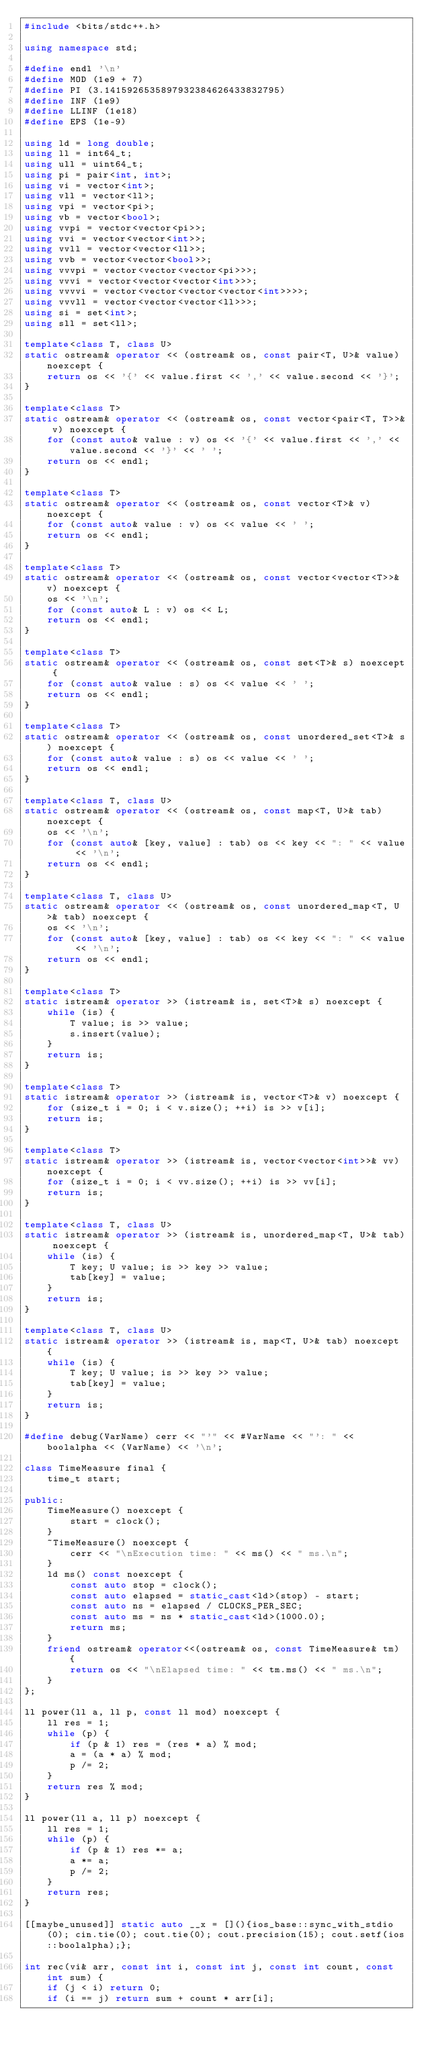Convert code to text. <code><loc_0><loc_0><loc_500><loc_500><_C++_>#include <bits/stdc++.h>

using namespace std;

#define endl '\n'
#define MOD (1e9 + 7)
#define PI (3.1415926535897932384626433832795)
#define INF (1e9)
#define LLINF (1e18)
#define EPS (1e-9)

using ld = long double;
using ll = int64_t;
using ull = uint64_t;
using pi = pair<int, int>;
using vi = vector<int>;
using vll = vector<ll>;
using vpi = vector<pi>;
using vb = vector<bool>;
using vvpi = vector<vector<pi>>;
using vvi = vector<vector<int>>;
using vvll = vector<vector<ll>>;
using vvb = vector<vector<bool>>;
using vvvpi = vector<vector<vector<pi>>>;
using vvvi = vector<vector<vector<int>>>;
using vvvvi = vector<vector<vector<vector<int>>>>;
using vvvll = vector<vector<vector<ll>>>;
using si = set<int>;
using sll = set<ll>;

template<class T, class U>
static ostream& operator << (ostream& os, const pair<T, U>& value) noexcept {
    return os << '{' << value.first << ',' << value.second << '}';
}

template<class T>
static ostream& operator << (ostream& os, const vector<pair<T, T>>& v) noexcept {
    for (const auto& value : v) os << '{' << value.first << ',' << value.second << '}' << ' ';
    return os << endl;
}

template<class T>
static ostream& operator << (ostream& os, const vector<T>& v) noexcept {
    for (const auto& value : v) os << value << ' ';
    return os << endl;
}

template<class T>
static ostream& operator << (ostream& os, const vector<vector<T>>& v) noexcept {
    os << '\n';
    for (const auto& L : v) os << L;
    return os << endl;
}

template<class T>
static ostream& operator << (ostream& os, const set<T>& s) noexcept {
    for (const auto& value : s) os << value << ' ';
    return os << endl;
}

template<class T>
static ostream& operator << (ostream& os, const unordered_set<T>& s) noexcept {
    for (const auto& value : s) os << value << ' ';
    return os << endl;
}

template<class T, class U>
static ostream& operator << (ostream& os, const map<T, U>& tab) noexcept {
    os << '\n';
    for (const auto& [key, value] : tab) os << key << ": " << value << '\n';
    return os << endl;
}

template<class T, class U>
static ostream& operator << (ostream& os, const unordered_map<T, U>& tab) noexcept {
    os << '\n';
    for (const auto& [key, value] : tab) os << key << ": " << value << '\n';
    return os << endl;
}

template<class T>
static istream& operator >> (istream& is, set<T>& s) noexcept {
    while (is) {
        T value; is >> value;
        s.insert(value);
    }
    return is;
}

template<class T>
static istream& operator >> (istream& is, vector<T>& v) noexcept {
    for (size_t i = 0; i < v.size(); ++i) is >> v[i];
    return is;
}

template<class T>
static istream& operator >> (istream& is, vector<vector<int>>& vv) noexcept {
    for (size_t i = 0; i < vv.size(); ++i) is >> vv[i];
    return is;
}

template<class T, class U>
static istream& operator >> (istream& is, unordered_map<T, U>& tab) noexcept {
    while (is) {
        T key; U value; is >> key >> value;
        tab[key] = value;
    }
    return is;
}

template<class T, class U>
static istream& operator >> (istream& is, map<T, U>& tab) noexcept {
    while (is) {
        T key; U value; is >> key >> value;
        tab[key] = value;
    }
    return is;
}

#define debug(VarName) cerr << "'" << #VarName << "': " << boolalpha << (VarName) << '\n';

class TimeMeasure final {
    time_t start;

public:
    TimeMeasure() noexcept {
        start = clock();
    }
    ~TimeMeasure() noexcept {
        cerr << "\nExecution time: " << ms() << " ms.\n";
    }
    ld ms() const noexcept {
        const auto stop = clock();
        const auto elapsed = static_cast<ld>(stop) - start;
        const auto ns = elapsed / CLOCKS_PER_SEC;
        const auto ms = ns * static_cast<ld>(1000.0);
        return ms;
    }
    friend ostream& operator<<(ostream& os, const TimeMeasure& tm) {
        return os << "\nElapsed time: " << tm.ms() << " ms.\n";
    }
};

ll power(ll a, ll p, const ll mod) noexcept {
    ll res = 1;
    while (p) {
        if (p & 1) res = (res * a) % mod;
        a = (a * a) % mod;
        p /= 2;
    }
    return res % mod;
}

ll power(ll a, ll p) noexcept {
    ll res = 1;
    while (p) {
        if (p & 1) res *= a;
        a *= a;
        p /= 2;
    }
    return res;
}

[[maybe_unused]] static auto __x = [](){ios_base::sync_with_stdio(0); cin.tie(0); cout.tie(0); cout.precision(15); cout.setf(ios::boolalpha);};

int rec(vi& arr, const int i, const int j, const int count, const int sum) {
    if (j < i) return 0;
    if (i == j) return sum + count * arr[i];</code> 